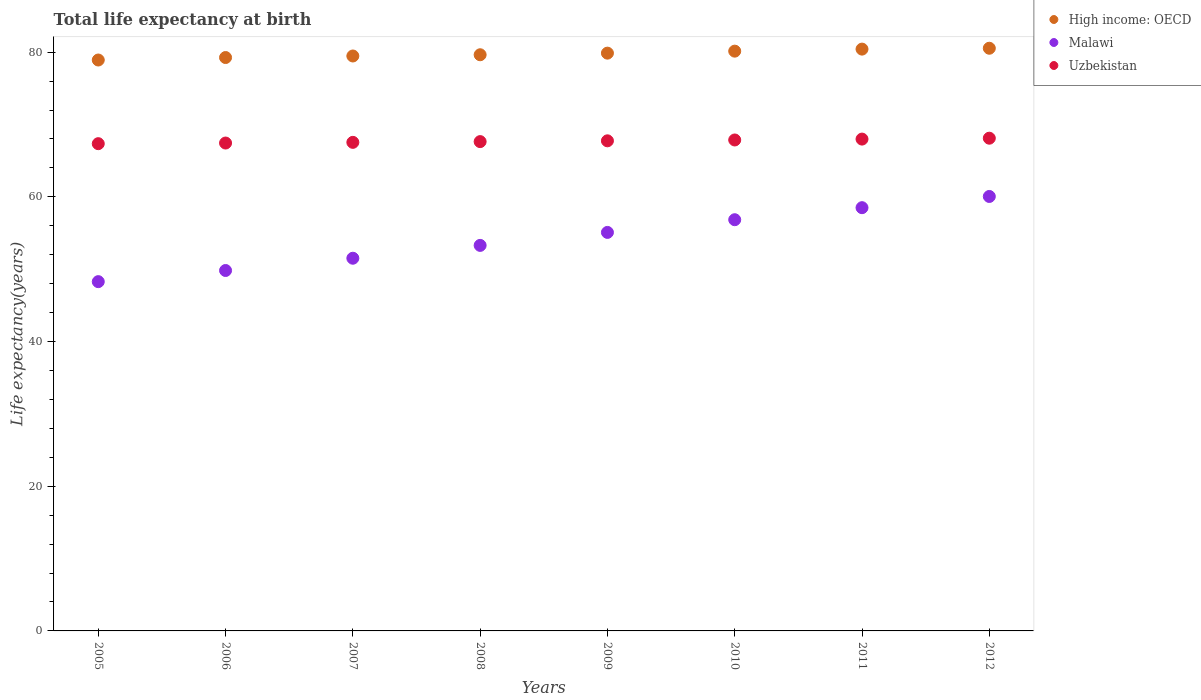How many different coloured dotlines are there?
Offer a very short reply. 3. Is the number of dotlines equal to the number of legend labels?
Your answer should be compact. Yes. What is the life expectancy at birth in in Malawi in 2006?
Give a very brief answer. 49.82. Across all years, what is the maximum life expectancy at birth in in Uzbekistan?
Your answer should be very brief. 68.1. Across all years, what is the minimum life expectancy at birth in in Uzbekistan?
Make the answer very short. 67.35. In which year was the life expectancy at birth in in High income: OECD maximum?
Your answer should be very brief. 2012. What is the total life expectancy at birth in in Uzbekistan in the graph?
Give a very brief answer. 541.63. What is the difference between the life expectancy at birth in in High income: OECD in 2008 and that in 2009?
Give a very brief answer. -0.22. What is the difference between the life expectancy at birth in in High income: OECD in 2005 and the life expectancy at birth in in Uzbekistan in 2007?
Your answer should be very brief. 11.38. What is the average life expectancy at birth in in Uzbekistan per year?
Provide a short and direct response. 67.7. In the year 2012, what is the difference between the life expectancy at birth in in Malawi and life expectancy at birth in in Uzbekistan?
Your answer should be very brief. -8.05. What is the ratio of the life expectancy at birth in in Malawi in 2006 to that in 2011?
Keep it short and to the point. 0.85. Is the life expectancy at birth in in Malawi in 2005 less than that in 2011?
Give a very brief answer. Yes. What is the difference between the highest and the second highest life expectancy at birth in in Uzbekistan?
Provide a short and direct response. 0.12. What is the difference between the highest and the lowest life expectancy at birth in in High income: OECD?
Provide a short and direct response. 1.63. Is the sum of the life expectancy at birth in in Uzbekistan in 2010 and 2012 greater than the maximum life expectancy at birth in in High income: OECD across all years?
Provide a succinct answer. Yes. Is it the case that in every year, the sum of the life expectancy at birth in in Uzbekistan and life expectancy at birth in in High income: OECD  is greater than the life expectancy at birth in in Malawi?
Give a very brief answer. Yes. Does the life expectancy at birth in in Uzbekistan monotonically increase over the years?
Provide a succinct answer. Yes. Is the life expectancy at birth in in Uzbekistan strictly greater than the life expectancy at birth in in High income: OECD over the years?
Offer a very short reply. No. How many dotlines are there?
Your answer should be very brief. 3. How many years are there in the graph?
Offer a very short reply. 8. What is the difference between two consecutive major ticks on the Y-axis?
Keep it short and to the point. 20. Where does the legend appear in the graph?
Make the answer very short. Top right. How many legend labels are there?
Ensure brevity in your answer.  3. How are the legend labels stacked?
Offer a very short reply. Vertical. What is the title of the graph?
Give a very brief answer. Total life expectancy at birth. Does "Upper middle income" appear as one of the legend labels in the graph?
Provide a succinct answer. No. What is the label or title of the X-axis?
Offer a very short reply. Years. What is the label or title of the Y-axis?
Ensure brevity in your answer.  Life expectancy(years). What is the Life expectancy(years) in High income: OECD in 2005?
Give a very brief answer. 78.91. What is the Life expectancy(years) of Malawi in 2005?
Offer a very short reply. 48.28. What is the Life expectancy(years) of Uzbekistan in 2005?
Ensure brevity in your answer.  67.35. What is the Life expectancy(years) of High income: OECD in 2006?
Your response must be concise. 79.25. What is the Life expectancy(years) in Malawi in 2006?
Your answer should be compact. 49.82. What is the Life expectancy(years) in Uzbekistan in 2006?
Ensure brevity in your answer.  67.44. What is the Life expectancy(years) in High income: OECD in 2007?
Offer a very short reply. 79.47. What is the Life expectancy(years) of Malawi in 2007?
Make the answer very short. 51.51. What is the Life expectancy(years) of Uzbekistan in 2007?
Your response must be concise. 67.53. What is the Life expectancy(years) in High income: OECD in 2008?
Give a very brief answer. 79.64. What is the Life expectancy(years) in Malawi in 2008?
Offer a very short reply. 53.29. What is the Life expectancy(years) of Uzbekistan in 2008?
Your response must be concise. 67.63. What is the Life expectancy(years) of High income: OECD in 2009?
Your response must be concise. 79.86. What is the Life expectancy(years) of Malawi in 2009?
Keep it short and to the point. 55.08. What is the Life expectancy(years) of Uzbekistan in 2009?
Offer a very short reply. 67.74. What is the Life expectancy(years) of High income: OECD in 2010?
Your answer should be compact. 80.14. What is the Life expectancy(years) in Malawi in 2010?
Make the answer very short. 56.84. What is the Life expectancy(years) in Uzbekistan in 2010?
Provide a short and direct response. 67.86. What is the Life expectancy(years) in High income: OECD in 2011?
Give a very brief answer. 80.42. What is the Life expectancy(years) in Malawi in 2011?
Offer a very short reply. 58.5. What is the Life expectancy(years) of Uzbekistan in 2011?
Make the answer very short. 67.98. What is the Life expectancy(years) in High income: OECD in 2012?
Offer a very short reply. 80.54. What is the Life expectancy(years) of Malawi in 2012?
Your answer should be compact. 60.05. What is the Life expectancy(years) of Uzbekistan in 2012?
Ensure brevity in your answer.  68.1. Across all years, what is the maximum Life expectancy(years) of High income: OECD?
Make the answer very short. 80.54. Across all years, what is the maximum Life expectancy(years) in Malawi?
Ensure brevity in your answer.  60.05. Across all years, what is the maximum Life expectancy(years) of Uzbekistan?
Your answer should be very brief. 68.1. Across all years, what is the minimum Life expectancy(years) in High income: OECD?
Ensure brevity in your answer.  78.91. Across all years, what is the minimum Life expectancy(years) of Malawi?
Your response must be concise. 48.28. Across all years, what is the minimum Life expectancy(years) in Uzbekistan?
Offer a terse response. 67.35. What is the total Life expectancy(years) in High income: OECD in the graph?
Give a very brief answer. 638.22. What is the total Life expectancy(years) in Malawi in the graph?
Your answer should be compact. 433.36. What is the total Life expectancy(years) in Uzbekistan in the graph?
Provide a succinct answer. 541.63. What is the difference between the Life expectancy(years) of High income: OECD in 2005 and that in 2006?
Offer a terse response. -0.34. What is the difference between the Life expectancy(years) in Malawi in 2005 and that in 2006?
Make the answer very short. -1.54. What is the difference between the Life expectancy(years) in Uzbekistan in 2005 and that in 2006?
Your answer should be very brief. -0.09. What is the difference between the Life expectancy(years) of High income: OECD in 2005 and that in 2007?
Keep it short and to the point. -0.56. What is the difference between the Life expectancy(years) in Malawi in 2005 and that in 2007?
Make the answer very short. -3.24. What is the difference between the Life expectancy(years) of Uzbekistan in 2005 and that in 2007?
Your response must be concise. -0.18. What is the difference between the Life expectancy(years) in High income: OECD in 2005 and that in 2008?
Offer a terse response. -0.73. What is the difference between the Life expectancy(years) of Malawi in 2005 and that in 2008?
Offer a very short reply. -5.01. What is the difference between the Life expectancy(years) in Uzbekistan in 2005 and that in 2008?
Ensure brevity in your answer.  -0.29. What is the difference between the Life expectancy(years) in High income: OECD in 2005 and that in 2009?
Provide a succinct answer. -0.95. What is the difference between the Life expectancy(years) in Malawi in 2005 and that in 2009?
Keep it short and to the point. -6.81. What is the difference between the Life expectancy(years) of Uzbekistan in 2005 and that in 2009?
Offer a very short reply. -0.4. What is the difference between the Life expectancy(years) in High income: OECD in 2005 and that in 2010?
Offer a very short reply. -1.23. What is the difference between the Life expectancy(years) in Malawi in 2005 and that in 2010?
Give a very brief answer. -8.56. What is the difference between the Life expectancy(years) of Uzbekistan in 2005 and that in 2010?
Ensure brevity in your answer.  -0.51. What is the difference between the Life expectancy(years) of High income: OECD in 2005 and that in 2011?
Offer a very short reply. -1.51. What is the difference between the Life expectancy(years) of Malawi in 2005 and that in 2011?
Ensure brevity in your answer.  -10.22. What is the difference between the Life expectancy(years) of Uzbekistan in 2005 and that in 2011?
Offer a terse response. -0.63. What is the difference between the Life expectancy(years) of High income: OECD in 2005 and that in 2012?
Your answer should be very brief. -1.63. What is the difference between the Life expectancy(years) in Malawi in 2005 and that in 2012?
Your answer should be compact. -11.77. What is the difference between the Life expectancy(years) of Uzbekistan in 2005 and that in 2012?
Give a very brief answer. -0.76. What is the difference between the Life expectancy(years) in High income: OECD in 2006 and that in 2007?
Your answer should be very brief. -0.21. What is the difference between the Life expectancy(years) of Malawi in 2006 and that in 2007?
Your response must be concise. -1.7. What is the difference between the Life expectancy(years) in Uzbekistan in 2006 and that in 2007?
Your response must be concise. -0.09. What is the difference between the Life expectancy(years) of High income: OECD in 2006 and that in 2008?
Provide a short and direct response. -0.38. What is the difference between the Life expectancy(years) of Malawi in 2006 and that in 2008?
Your answer should be compact. -3.47. What is the difference between the Life expectancy(years) of Uzbekistan in 2006 and that in 2008?
Give a very brief answer. -0.2. What is the difference between the Life expectancy(years) in High income: OECD in 2006 and that in 2009?
Ensure brevity in your answer.  -0.61. What is the difference between the Life expectancy(years) in Malawi in 2006 and that in 2009?
Offer a very short reply. -5.27. What is the difference between the Life expectancy(years) in Uzbekistan in 2006 and that in 2009?
Your answer should be very brief. -0.31. What is the difference between the Life expectancy(years) in High income: OECD in 2006 and that in 2010?
Provide a succinct answer. -0.88. What is the difference between the Life expectancy(years) of Malawi in 2006 and that in 2010?
Give a very brief answer. -7.02. What is the difference between the Life expectancy(years) in Uzbekistan in 2006 and that in 2010?
Your answer should be very brief. -0.42. What is the difference between the Life expectancy(years) of High income: OECD in 2006 and that in 2011?
Provide a succinct answer. -1.16. What is the difference between the Life expectancy(years) in Malawi in 2006 and that in 2011?
Offer a terse response. -8.68. What is the difference between the Life expectancy(years) in Uzbekistan in 2006 and that in 2011?
Give a very brief answer. -0.55. What is the difference between the Life expectancy(years) of High income: OECD in 2006 and that in 2012?
Offer a very short reply. -1.28. What is the difference between the Life expectancy(years) of Malawi in 2006 and that in 2012?
Keep it short and to the point. -10.23. What is the difference between the Life expectancy(years) in Uzbekistan in 2006 and that in 2012?
Make the answer very short. -0.67. What is the difference between the Life expectancy(years) in High income: OECD in 2007 and that in 2008?
Give a very brief answer. -0.17. What is the difference between the Life expectancy(years) of Malawi in 2007 and that in 2008?
Provide a short and direct response. -1.77. What is the difference between the Life expectancy(years) of Uzbekistan in 2007 and that in 2008?
Your response must be concise. -0.1. What is the difference between the Life expectancy(years) in High income: OECD in 2007 and that in 2009?
Provide a succinct answer. -0.39. What is the difference between the Life expectancy(years) in Malawi in 2007 and that in 2009?
Provide a short and direct response. -3.57. What is the difference between the Life expectancy(years) in Uzbekistan in 2007 and that in 2009?
Provide a succinct answer. -0.21. What is the difference between the Life expectancy(years) in High income: OECD in 2007 and that in 2010?
Make the answer very short. -0.67. What is the difference between the Life expectancy(years) in Malawi in 2007 and that in 2010?
Your answer should be very brief. -5.32. What is the difference between the Life expectancy(years) in Uzbekistan in 2007 and that in 2010?
Your answer should be very brief. -0.33. What is the difference between the Life expectancy(years) of High income: OECD in 2007 and that in 2011?
Offer a very short reply. -0.95. What is the difference between the Life expectancy(years) in Malawi in 2007 and that in 2011?
Your response must be concise. -6.99. What is the difference between the Life expectancy(years) in Uzbekistan in 2007 and that in 2011?
Your answer should be compact. -0.45. What is the difference between the Life expectancy(years) in High income: OECD in 2007 and that in 2012?
Make the answer very short. -1.07. What is the difference between the Life expectancy(years) of Malawi in 2007 and that in 2012?
Make the answer very short. -8.54. What is the difference between the Life expectancy(years) of Uzbekistan in 2007 and that in 2012?
Your answer should be compact. -0.57. What is the difference between the Life expectancy(years) in High income: OECD in 2008 and that in 2009?
Offer a terse response. -0.22. What is the difference between the Life expectancy(years) of Malawi in 2008 and that in 2009?
Make the answer very short. -1.79. What is the difference between the Life expectancy(years) in Uzbekistan in 2008 and that in 2009?
Ensure brevity in your answer.  -0.11. What is the difference between the Life expectancy(years) in High income: OECD in 2008 and that in 2010?
Provide a short and direct response. -0.5. What is the difference between the Life expectancy(years) in Malawi in 2008 and that in 2010?
Offer a very short reply. -3.55. What is the difference between the Life expectancy(years) of Uzbekistan in 2008 and that in 2010?
Your response must be concise. -0.23. What is the difference between the Life expectancy(years) of High income: OECD in 2008 and that in 2011?
Make the answer very short. -0.78. What is the difference between the Life expectancy(years) of Malawi in 2008 and that in 2011?
Provide a succinct answer. -5.21. What is the difference between the Life expectancy(years) in Uzbekistan in 2008 and that in 2011?
Give a very brief answer. -0.35. What is the difference between the Life expectancy(years) in High income: OECD in 2008 and that in 2012?
Your response must be concise. -0.9. What is the difference between the Life expectancy(years) of Malawi in 2008 and that in 2012?
Ensure brevity in your answer.  -6.76. What is the difference between the Life expectancy(years) in Uzbekistan in 2008 and that in 2012?
Ensure brevity in your answer.  -0.47. What is the difference between the Life expectancy(years) of High income: OECD in 2009 and that in 2010?
Provide a succinct answer. -0.28. What is the difference between the Life expectancy(years) of Malawi in 2009 and that in 2010?
Your response must be concise. -1.75. What is the difference between the Life expectancy(years) in Uzbekistan in 2009 and that in 2010?
Your answer should be very brief. -0.12. What is the difference between the Life expectancy(years) in High income: OECD in 2009 and that in 2011?
Keep it short and to the point. -0.56. What is the difference between the Life expectancy(years) in Malawi in 2009 and that in 2011?
Make the answer very short. -3.42. What is the difference between the Life expectancy(years) of Uzbekistan in 2009 and that in 2011?
Ensure brevity in your answer.  -0.24. What is the difference between the Life expectancy(years) of High income: OECD in 2009 and that in 2012?
Keep it short and to the point. -0.68. What is the difference between the Life expectancy(years) of Malawi in 2009 and that in 2012?
Provide a short and direct response. -4.97. What is the difference between the Life expectancy(years) in Uzbekistan in 2009 and that in 2012?
Provide a short and direct response. -0.36. What is the difference between the Life expectancy(years) of High income: OECD in 2010 and that in 2011?
Make the answer very short. -0.28. What is the difference between the Life expectancy(years) in Malawi in 2010 and that in 2011?
Your response must be concise. -1.66. What is the difference between the Life expectancy(years) of Uzbekistan in 2010 and that in 2011?
Your answer should be compact. -0.12. What is the difference between the Life expectancy(years) of High income: OECD in 2010 and that in 2012?
Offer a terse response. -0.4. What is the difference between the Life expectancy(years) in Malawi in 2010 and that in 2012?
Provide a succinct answer. -3.21. What is the difference between the Life expectancy(years) of Uzbekistan in 2010 and that in 2012?
Ensure brevity in your answer.  -0.25. What is the difference between the Life expectancy(years) of High income: OECD in 2011 and that in 2012?
Provide a short and direct response. -0.12. What is the difference between the Life expectancy(years) of Malawi in 2011 and that in 2012?
Provide a short and direct response. -1.55. What is the difference between the Life expectancy(years) in Uzbekistan in 2011 and that in 2012?
Offer a very short reply. -0.12. What is the difference between the Life expectancy(years) in High income: OECD in 2005 and the Life expectancy(years) in Malawi in 2006?
Provide a succinct answer. 29.09. What is the difference between the Life expectancy(years) of High income: OECD in 2005 and the Life expectancy(years) of Uzbekistan in 2006?
Your answer should be compact. 11.48. What is the difference between the Life expectancy(years) of Malawi in 2005 and the Life expectancy(years) of Uzbekistan in 2006?
Give a very brief answer. -19.16. What is the difference between the Life expectancy(years) of High income: OECD in 2005 and the Life expectancy(years) of Malawi in 2007?
Your answer should be very brief. 27.4. What is the difference between the Life expectancy(years) of High income: OECD in 2005 and the Life expectancy(years) of Uzbekistan in 2007?
Give a very brief answer. 11.38. What is the difference between the Life expectancy(years) in Malawi in 2005 and the Life expectancy(years) in Uzbekistan in 2007?
Your response must be concise. -19.25. What is the difference between the Life expectancy(years) of High income: OECD in 2005 and the Life expectancy(years) of Malawi in 2008?
Offer a very short reply. 25.62. What is the difference between the Life expectancy(years) of High income: OECD in 2005 and the Life expectancy(years) of Uzbekistan in 2008?
Your answer should be very brief. 11.28. What is the difference between the Life expectancy(years) in Malawi in 2005 and the Life expectancy(years) in Uzbekistan in 2008?
Provide a succinct answer. -19.36. What is the difference between the Life expectancy(years) of High income: OECD in 2005 and the Life expectancy(years) of Malawi in 2009?
Make the answer very short. 23.83. What is the difference between the Life expectancy(years) of High income: OECD in 2005 and the Life expectancy(years) of Uzbekistan in 2009?
Offer a terse response. 11.17. What is the difference between the Life expectancy(years) of Malawi in 2005 and the Life expectancy(years) of Uzbekistan in 2009?
Offer a terse response. -19.47. What is the difference between the Life expectancy(years) of High income: OECD in 2005 and the Life expectancy(years) of Malawi in 2010?
Keep it short and to the point. 22.07. What is the difference between the Life expectancy(years) of High income: OECD in 2005 and the Life expectancy(years) of Uzbekistan in 2010?
Make the answer very short. 11.05. What is the difference between the Life expectancy(years) in Malawi in 2005 and the Life expectancy(years) in Uzbekistan in 2010?
Give a very brief answer. -19.58. What is the difference between the Life expectancy(years) in High income: OECD in 2005 and the Life expectancy(years) in Malawi in 2011?
Ensure brevity in your answer.  20.41. What is the difference between the Life expectancy(years) in High income: OECD in 2005 and the Life expectancy(years) in Uzbekistan in 2011?
Your answer should be very brief. 10.93. What is the difference between the Life expectancy(years) of Malawi in 2005 and the Life expectancy(years) of Uzbekistan in 2011?
Keep it short and to the point. -19.7. What is the difference between the Life expectancy(years) of High income: OECD in 2005 and the Life expectancy(years) of Malawi in 2012?
Keep it short and to the point. 18.86. What is the difference between the Life expectancy(years) in High income: OECD in 2005 and the Life expectancy(years) in Uzbekistan in 2012?
Give a very brief answer. 10.81. What is the difference between the Life expectancy(years) in Malawi in 2005 and the Life expectancy(years) in Uzbekistan in 2012?
Offer a terse response. -19.83. What is the difference between the Life expectancy(years) in High income: OECD in 2006 and the Life expectancy(years) in Malawi in 2007?
Offer a very short reply. 27.74. What is the difference between the Life expectancy(years) of High income: OECD in 2006 and the Life expectancy(years) of Uzbekistan in 2007?
Ensure brevity in your answer.  11.72. What is the difference between the Life expectancy(years) in Malawi in 2006 and the Life expectancy(years) in Uzbekistan in 2007?
Your response must be concise. -17.71. What is the difference between the Life expectancy(years) of High income: OECD in 2006 and the Life expectancy(years) of Malawi in 2008?
Give a very brief answer. 25.97. What is the difference between the Life expectancy(years) of High income: OECD in 2006 and the Life expectancy(years) of Uzbekistan in 2008?
Offer a very short reply. 11.62. What is the difference between the Life expectancy(years) in Malawi in 2006 and the Life expectancy(years) in Uzbekistan in 2008?
Your response must be concise. -17.82. What is the difference between the Life expectancy(years) in High income: OECD in 2006 and the Life expectancy(years) in Malawi in 2009?
Your answer should be very brief. 24.17. What is the difference between the Life expectancy(years) of High income: OECD in 2006 and the Life expectancy(years) of Uzbekistan in 2009?
Make the answer very short. 11.51. What is the difference between the Life expectancy(years) in Malawi in 2006 and the Life expectancy(years) in Uzbekistan in 2009?
Offer a very short reply. -17.93. What is the difference between the Life expectancy(years) of High income: OECD in 2006 and the Life expectancy(years) of Malawi in 2010?
Your response must be concise. 22.42. What is the difference between the Life expectancy(years) of High income: OECD in 2006 and the Life expectancy(years) of Uzbekistan in 2010?
Ensure brevity in your answer.  11.39. What is the difference between the Life expectancy(years) of Malawi in 2006 and the Life expectancy(years) of Uzbekistan in 2010?
Your answer should be compact. -18.04. What is the difference between the Life expectancy(years) in High income: OECD in 2006 and the Life expectancy(years) in Malawi in 2011?
Keep it short and to the point. 20.75. What is the difference between the Life expectancy(years) in High income: OECD in 2006 and the Life expectancy(years) in Uzbekistan in 2011?
Give a very brief answer. 11.27. What is the difference between the Life expectancy(years) of Malawi in 2006 and the Life expectancy(years) of Uzbekistan in 2011?
Keep it short and to the point. -18.16. What is the difference between the Life expectancy(years) in High income: OECD in 2006 and the Life expectancy(years) in Malawi in 2012?
Ensure brevity in your answer.  19.2. What is the difference between the Life expectancy(years) of High income: OECD in 2006 and the Life expectancy(years) of Uzbekistan in 2012?
Make the answer very short. 11.15. What is the difference between the Life expectancy(years) in Malawi in 2006 and the Life expectancy(years) in Uzbekistan in 2012?
Give a very brief answer. -18.29. What is the difference between the Life expectancy(years) in High income: OECD in 2007 and the Life expectancy(years) in Malawi in 2008?
Your answer should be compact. 26.18. What is the difference between the Life expectancy(years) of High income: OECD in 2007 and the Life expectancy(years) of Uzbekistan in 2008?
Make the answer very short. 11.84. What is the difference between the Life expectancy(years) of Malawi in 2007 and the Life expectancy(years) of Uzbekistan in 2008?
Give a very brief answer. -16.12. What is the difference between the Life expectancy(years) of High income: OECD in 2007 and the Life expectancy(years) of Malawi in 2009?
Provide a succinct answer. 24.38. What is the difference between the Life expectancy(years) in High income: OECD in 2007 and the Life expectancy(years) in Uzbekistan in 2009?
Offer a terse response. 11.73. What is the difference between the Life expectancy(years) of Malawi in 2007 and the Life expectancy(years) of Uzbekistan in 2009?
Your answer should be very brief. -16.23. What is the difference between the Life expectancy(years) of High income: OECD in 2007 and the Life expectancy(years) of Malawi in 2010?
Your response must be concise. 22.63. What is the difference between the Life expectancy(years) in High income: OECD in 2007 and the Life expectancy(years) in Uzbekistan in 2010?
Your response must be concise. 11.61. What is the difference between the Life expectancy(years) of Malawi in 2007 and the Life expectancy(years) of Uzbekistan in 2010?
Ensure brevity in your answer.  -16.35. What is the difference between the Life expectancy(years) of High income: OECD in 2007 and the Life expectancy(years) of Malawi in 2011?
Provide a short and direct response. 20.97. What is the difference between the Life expectancy(years) of High income: OECD in 2007 and the Life expectancy(years) of Uzbekistan in 2011?
Offer a terse response. 11.49. What is the difference between the Life expectancy(years) in Malawi in 2007 and the Life expectancy(years) in Uzbekistan in 2011?
Provide a succinct answer. -16.47. What is the difference between the Life expectancy(years) in High income: OECD in 2007 and the Life expectancy(years) in Malawi in 2012?
Your answer should be very brief. 19.42. What is the difference between the Life expectancy(years) of High income: OECD in 2007 and the Life expectancy(years) of Uzbekistan in 2012?
Provide a succinct answer. 11.36. What is the difference between the Life expectancy(years) of Malawi in 2007 and the Life expectancy(years) of Uzbekistan in 2012?
Offer a very short reply. -16.59. What is the difference between the Life expectancy(years) in High income: OECD in 2008 and the Life expectancy(years) in Malawi in 2009?
Offer a very short reply. 24.55. What is the difference between the Life expectancy(years) of High income: OECD in 2008 and the Life expectancy(years) of Uzbekistan in 2009?
Provide a succinct answer. 11.89. What is the difference between the Life expectancy(years) of Malawi in 2008 and the Life expectancy(years) of Uzbekistan in 2009?
Give a very brief answer. -14.45. What is the difference between the Life expectancy(years) in High income: OECD in 2008 and the Life expectancy(years) in Malawi in 2010?
Keep it short and to the point. 22.8. What is the difference between the Life expectancy(years) in High income: OECD in 2008 and the Life expectancy(years) in Uzbekistan in 2010?
Offer a terse response. 11.78. What is the difference between the Life expectancy(years) in Malawi in 2008 and the Life expectancy(years) in Uzbekistan in 2010?
Give a very brief answer. -14.57. What is the difference between the Life expectancy(years) in High income: OECD in 2008 and the Life expectancy(years) in Malawi in 2011?
Your answer should be very brief. 21.14. What is the difference between the Life expectancy(years) of High income: OECD in 2008 and the Life expectancy(years) of Uzbekistan in 2011?
Your response must be concise. 11.66. What is the difference between the Life expectancy(years) in Malawi in 2008 and the Life expectancy(years) in Uzbekistan in 2011?
Ensure brevity in your answer.  -14.69. What is the difference between the Life expectancy(years) in High income: OECD in 2008 and the Life expectancy(years) in Malawi in 2012?
Provide a short and direct response. 19.59. What is the difference between the Life expectancy(years) of High income: OECD in 2008 and the Life expectancy(years) of Uzbekistan in 2012?
Make the answer very short. 11.53. What is the difference between the Life expectancy(years) in Malawi in 2008 and the Life expectancy(years) in Uzbekistan in 2012?
Give a very brief answer. -14.82. What is the difference between the Life expectancy(years) in High income: OECD in 2009 and the Life expectancy(years) in Malawi in 2010?
Your answer should be very brief. 23.02. What is the difference between the Life expectancy(years) in High income: OECD in 2009 and the Life expectancy(years) in Uzbekistan in 2010?
Offer a very short reply. 12. What is the difference between the Life expectancy(years) of Malawi in 2009 and the Life expectancy(years) of Uzbekistan in 2010?
Offer a terse response. -12.78. What is the difference between the Life expectancy(years) of High income: OECD in 2009 and the Life expectancy(years) of Malawi in 2011?
Your response must be concise. 21.36. What is the difference between the Life expectancy(years) in High income: OECD in 2009 and the Life expectancy(years) in Uzbekistan in 2011?
Offer a very short reply. 11.88. What is the difference between the Life expectancy(years) in Malawi in 2009 and the Life expectancy(years) in Uzbekistan in 2011?
Your answer should be compact. -12.9. What is the difference between the Life expectancy(years) in High income: OECD in 2009 and the Life expectancy(years) in Malawi in 2012?
Offer a very short reply. 19.81. What is the difference between the Life expectancy(years) of High income: OECD in 2009 and the Life expectancy(years) of Uzbekistan in 2012?
Give a very brief answer. 11.76. What is the difference between the Life expectancy(years) in Malawi in 2009 and the Life expectancy(years) in Uzbekistan in 2012?
Your answer should be compact. -13.02. What is the difference between the Life expectancy(years) of High income: OECD in 2010 and the Life expectancy(years) of Malawi in 2011?
Your answer should be compact. 21.64. What is the difference between the Life expectancy(years) of High income: OECD in 2010 and the Life expectancy(years) of Uzbekistan in 2011?
Provide a succinct answer. 12.16. What is the difference between the Life expectancy(years) of Malawi in 2010 and the Life expectancy(years) of Uzbekistan in 2011?
Provide a short and direct response. -11.14. What is the difference between the Life expectancy(years) of High income: OECD in 2010 and the Life expectancy(years) of Malawi in 2012?
Make the answer very short. 20.09. What is the difference between the Life expectancy(years) in High income: OECD in 2010 and the Life expectancy(years) in Uzbekistan in 2012?
Offer a very short reply. 12.03. What is the difference between the Life expectancy(years) of Malawi in 2010 and the Life expectancy(years) of Uzbekistan in 2012?
Give a very brief answer. -11.27. What is the difference between the Life expectancy(years) in High income: OECD in 2011 and the Life expectancy(years) in Malawi in 2012?
Provide a succinct answer. 20.37. What is the difference between the Life expectancy(years) of High income: OECD in 2011 and the Life expectancy(years) of Uzbekistan in 2012?
Your response must be concise. 12.31. What is the difference between the Life expectancy(years) in Malawi in 2011 and the Life expectancy(years) in Uzbekistan in 2012?
Make the answer very short. -9.6. What is the average Life expectancy(years) in High income: OECD per year?
Offer a very short reply. 79.78. What is the average Life expectancy(years) of Malawi per year?
Keep it short and to the point. 54.17. What is the average Life expectancy(years) of Uzbekistan per year?
Your answer should be compact. 67.7. In the year 2005, what is the difference between the Life expectancy(years) in High income: OECD and Life expectancy(years) in Malawi?
Ensure brevity in your answer.  30.63. In the year 2005, what is the difference between the Life expectancy(years) in High income: OECD and Life expectancy(years) in Uzbekistan?
Make the answer very short. 11.56. In the year 2005, what is the difference between the Life expectancy(years) of Malawi and Life expectancy(years) of Uzbekistan?
Your response must be concise. -19.07. In the year 2006, what is the difference between the Life expectancy(years) of High income: OECD and Life expectancy(years) of Malawi?
Keep it short and to the point. 29.44. In the year 2006, what is the difference between the Life expectancy(years) of High income: OECD and Life expectancy(years) of Uzbekistan?
Offer a terse response. 11.82. In the year 2006, what is the difference between the Life expectancy(years) in Malawi and Life expectancy(years) in Uzbekistan?
Your answer should be compact. -17.62. In the year 2007, what is the difference between the Life expectancy(years) in High income: OECD and Life expectancy(years) in Malawi?
Make the answer very short. 27.95. In the year 2007, what is the difference between the Life expectancy(years) in High income: OECD and Life expectancy(years) in Uzbekistan?
Offer a terse response. 11.94. In the year 2007, what is the difference between the Life expectancy(years) in Malawi and Life expectancy(years) in Uzbekistan?
Give a very brief answer. -16.02. In the year 2008, what is the difference between the Life expectancy(years) of High income: OECD and Life expectancy(years) of Malawi?
Ensure brevity in your answer.  26.35. In the year 2008, what is the difference between the Life expectancy(years) of High income: OECD and Life expectancy(years) of Uzbekistan?
Your answer should be very brief. 12. In the year 2008, what is the difference between the Life expectancy(years) of Malawi and Life expectancy(years) of Uzbekistan?
Give a very brief answer. -14.34. In the year 2009, what is the difference between the Life expectancy(years) of High income: OECD and Life expectancy(years) of Malawi?
Your answer should be very brief. 24.78. In the year 2009, what is the difference between the Life expectancy(years) of High income: OECD and Life expectancy(years) of Uzbekistan?
Offer a terse response. 12.12. In the year 2009, what is the difference between the Life expectancy(years) in Malawi and Life expectancy(years) in Uzbekistan?
Offer a very short reply. -12.66. In the year 2010, what is the difference between the Life expectancy(years) of High income: OECD and Life expectancy(years) of Malawi?
Offer a terse response. 23.3. In the year 2010, what is the difference between the Life expectancy(years) of High income: OECD and Life expectancy(years) of Uzbekistan?
Offer a terse response. 12.28. In the year 2010, what is the difference between the Life expectancy(years) of Malawi and Life expectancy(years) of Uzbekistan?
Provide a succinct answer. -11.02. In the year 2011, what is the difference between the Life expectancy(years) in High income: OECD and Life expectancy(years) in Malawi?
Ensure brevity in your answer.  21.92. In the year 2011, what is the difference between the Life expectancy(years) of High income: OECD and Life expectancy(years) of Uzbekistan?
Provide a short and direct response. 12.44. In the year 2011, what is the difference between the Life expectancy(years) in Malawi and Life expectancy(years) in Uzbekistan?
Your answer should be very brief. -9.48. In the year 2012, what is the difference between the Life expectancy(years) of High income: OECD and Life expectancy(years) of Malawi?
Make the answer very short. 20.49. In the year 2012, what is the difference between the Life expectancy(years) of High income: OECD and Life expectancy(years) of Uzbekistan?
Your answer should be very brief. 12.43. In the year 2012, what is the difference between the Life expectancy(years) of Malawi and Life expectancy(years) of Uzbekistan?
Offer a very short reply. -8.05. What is the ratio of the Life expectancy(years) of Malawi in 2005 to that in 2006?
Offer a terse response. 0.97. What is the ratio of the Life expectancy(years) of Uzbekistan in 2005 to that in 2006?
Provide a short and direct response. 1. What is the ratio of the Life expectancy(years) in High income: OECD in 2005 to that in 2007?
Keep it short and to the point. 0.99. What is the ratio of the Life expectancy(years) in Malawi in 2005 to that in 2007?
Keep it short and to the point. 0.94. What is the ratio of the Life expectancy(years) in Uzbekistan in 2005 to that in 2007?
Your answer should be compact. 1. What is the ratio of the Life expectancy(years) of High income: OECD in 2005 to that in 2008?
Ensure brevity in your answer.  0.99. What is the ratio of the Life expectancy(years) in Malawi in 2005 to that in 2008?
Provide a succinct answer. 0.91. What is the ratio of the Life expectancy(years) in High income: OECD in 2005 to that in 2009?
Give a very brief answer. 0.99. What is the ratio of the Life expectancy(years) of Malawi in 2005 to that in 2009?
Make the answer very short. 0.88. What is the ratio of the Life expectancy(years) of Uzbekistan in 2005 to that in 2009?
Ensure brevity in your answer.  0.99. What is the ratio of the Life expectancy(years) of High income: OECD in 2005 to that in 2010?
Your response must be concise. 0.98. What is the ratio of the Life expectancy(years) of Malawi in 2005 to that in 2010?
Your answer should be very brief. 0.85. What is the ratio of the Life expectancy(years) of High income: OECD in 2005 to that in 2011?
Make the answer very short. 0.98. What is the ratio of the Life expectancy(years) of Malawi in 2005 to that in 2011?
Give a very brief answer. 0.83. What is the ratio of the Life expectancy(years) in High income: OECD in 2005 to that in 2012?
Give a very brief answer. 0.98. What is the ratio of the Life expectancy(years) in Malawi in 2005 to that in 2012?
Ensure brevity in your answer.  0.8. What is the ratio of the Life expectancy(years) of Uzbekistan in 2005 to that in 2012?
Offer a very short reply. 0.99. What is the ratio of the Life expectancy(years) in Malawi in 2006 to that in 2007?
Give a very brief answer. 0.97. What is the ratio of the Life expectancy(years) in Malawi in 2006 to that in 2008?
Provide a short and direct response. 0.93. What is the ratio of the Life expectancy(years) in Uzbekistan in 2006 to that in 2008?
Offer a terse response. 1. What is the ratio of the Life expectancy(years) of Malawi in 2006 to that in 2009?
Make the answer very short. 0.9. What is the ratio of the Life expectancy(years) in Malawi in 2006 to that in 2010?
Your answer should be compact. 0.88. What is the ratio of the Life expectancy(years) of Uzbekistan in 2006 to that in 2010?
Offer a terse response. 0.99. What is the ratio of the Life expectancy(years) in High income: OECD in 2006 to that in 2011?
Give a very brief answer. 0.99. What is the ratio of the Life expectancy(years) of Malawi in 2006 to that in 2011?
Your answer should be compact. 0.85. What is the ratio of the Life expectancy(years) of High income: OECD in 2006 to that in 2012?
Give a very brief answer. 0.98. What is the ratio of the Life expectancy(years) of Malawi in 2006 to that in 2012?
Make the answer very short. 0.83. What is the ratio of the Life expectancy(years) in Uzbekistan in 2006 to that in 2012?
Make the answer very short. 0.99. What is the ratio of the Life expectancy(years) in High income: OECD in 2007 to that in 2008?
Make the answer very short. 1. What is the ratio of the Life expectancy(years) in Malawi in 2007 to that in 2008?
Your answer should be compact. 0.97. What is the ratio of the Life expectancy(years) in Uzbekistan in 2007 to that in 2008?
Keep it short and to the point. 1. What is the ratio of the Life expectancy(years) of High income: OECD in 2007 to that in 2009?
Offer a terse response. 1. What is the ratio of the Life expectancy(years) of Malawi in 2007 to that in 2009?
Offer a terse response. 0.94. What is the ratio of the Life expectancy(years) in Uzbekistan in 2007 to that in 2009?
Offer a very short reply. 1. What is the ratio of the Life expectancy(years) in Malawi in 2007 to that in 2010?
Ensure brevity in your answer.  0.91. What is the ratio of the Life expectancy(years) of High income: OECD in 2007 to that in 2011?
Offer a very short reply. 0.99. What is the ratio of the Life expectancy(years) in Malawi in 2007 to that in 2011?
Provide a short and direct response. 0.88. What is the ratio of the Life expectancy(years) in High income: OECD in 2007 to that in 2012?
Your response must be concise. 0.99. What is the ratio of the Life expectancy(years) of Malawi in 2007 to that in 2012?
Ensure brevity in your answer.  0.86. What is the ratio of the Life expectancy(years) of High income: OECD in 2008 to that in 2009?
Provide a short and direct response. 1. What is the ratio of the Life expectancy(years) in Malawi in 2008 to that in 2009?
Give a very brief answer. 0.97. What is the ratio of the Life expectancy(years) in Uzbekistan in 2008 to that in 2009?
Your answer should be compact. 1. What is the ratio of the Life expectancy(years) of Malawi in 2008 to that in 2010?
Provide a short and direct response. 0.94. What is the ratio of the Life expectancy(years) in High income: OECD in 2008 to that in 2011?
Make the answer very short. 0.99. What is the ratio of the Life expectancy(years) of Malawi in 2008 to that in 2011?
Ensure brevity in your answer.  0.91. What is the ratio of the Life expectancy(years) in Uzbekistan in 2008 to that in 2011?
Provide a succinct answer. 0.99. What is the ratio of the Life expectancy(years) in High income: OECD in 2008 to that in 2012?
Make the answer very short. 0.99. What is the ratio of the Life expectancy(years) in Malawi in 2008 to that in 2012?
Your answer should be very brief. 0.89. What is the ratio of the Life expectancy(years) of Uzbekistan in 2008 to that in 2012?
Provide a succinct answer. 0.99. What is the ratio of the Life expectancy(years) in High income: OECD in 2009 to that in 2010?
Offer a terse response. 1. What is the ratio of the Life expectancy(years) of Malawi in 2009 to that in 2010?
Offer a terse response. 0.97. What is the ratio of the Life expectancy(years) in High income: OECD in 2009 to that in 2011?
Provide a succinct answer. 0.99. What is the ratio of the Life expectancy(years) of Malawi in 2009 to that in 2011?
Your response must be concise. 0.94. What is the ratio of the Life expectancy(years) in Uzbekistan in 2009 to that in 2011?
Offer a terse response. 1. What is the ratio of the Life expectancy(years) of High income: OECD in 2009 to that in 2012?
Offer a very short reply. 0.99. What is the ratio of the Life expectancy(years) in Malawi in 2009 to that in 2012?
Your response must be concise. 0.92. What is the ratio of the Life expectancy(years) in Uzbekistan in 2009 to that in 2012?
Provide a short and direct response. 0.99. What is the ratio of the Life expectancy(years) of High income: OECD in 2010 to that in 2011?
Your response must be concise. 1. What is the ratio of the Life expectancy(years) in Malawi in 2010 to that in 2011?
Provide a short and direct response. 0.97. What is the ratio of the Life expectancy(years) of Uzbekistan in 2010 to that in 2011?
Your answer should be compact. 1. What is the ratio of the Life expectancy(years) of High income: OECD in 2010 to that in 2012?
Provide a succinct answer. 0.99. What is the ratio of the Life expectancy(years) in Malawi in 2010 to that in 2012?
Your answer should be very brief. 0.95. What is the ratio of the Life expectancy(years) of Malawi in 2011 to that in 2012?
Offer a very short reply. 0.97. What is the difference between the highest and the second highest Life expectancy(years) of High income: OECD?
Your response must be concise. 0.12. What is the difference between the highest and the second highest Life expectancy(years) in Malawi?
Your response must be concise. 1.55. What is the difference between the highest and the second highest Life expectancy(years) of Uzbekistan?
Offer a very short reply. 0.12. What is the difference between the highest and the lowest Life expectancy(years) in High income: OECD?
Provide a short and direct response. 1.63. What is the difference between the highest and the lowest Life expectancy(years) of Malawi?
Offer a terse response. 11.77. What is the difference between the highest and the lowest Life expectancy(years) of Uzbekistan?
Ensure brevity in your answer.  0.76. 